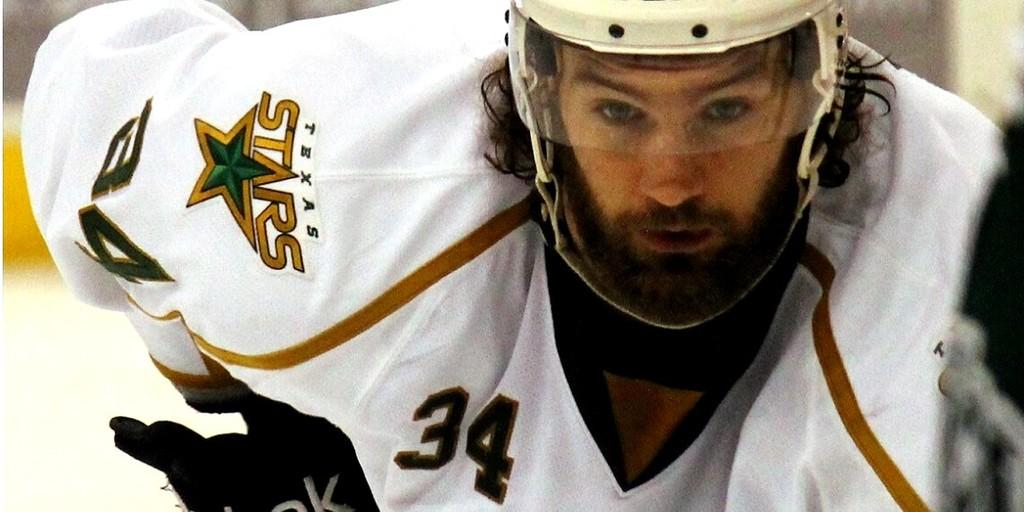What is the main subject of the image? There is a person in the image. What type of clothing is the person wearing? The person is wearing a sports dress. What protective gear is the person wearing? The person is wearing a helmet. What historical event is depicted in the image? There is no historical event depicted in the image; it features a person wearing a sports dress and a helmet. How does the person's appearance change when they look at the camera? The image does not show the person looking at the camera, so it cannot be determined how their appearance changes. 